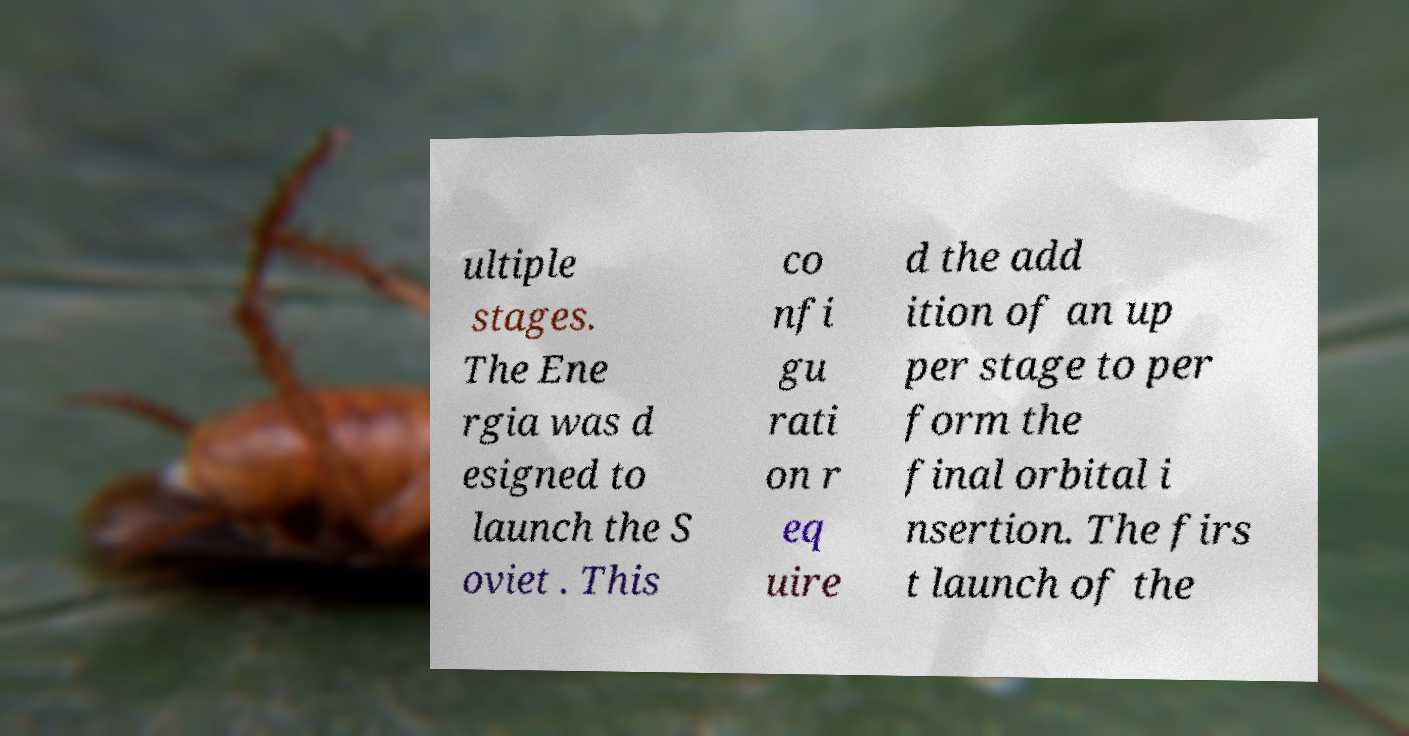Could you extract and type out the text from this image? ultiple stages. The Ene rgia was d esigned to launch the S oviet . This co nfi gu rati on r eq uire d the add ition of an up per stage to per form the final orbital i nsertion. The firs t launch of the 